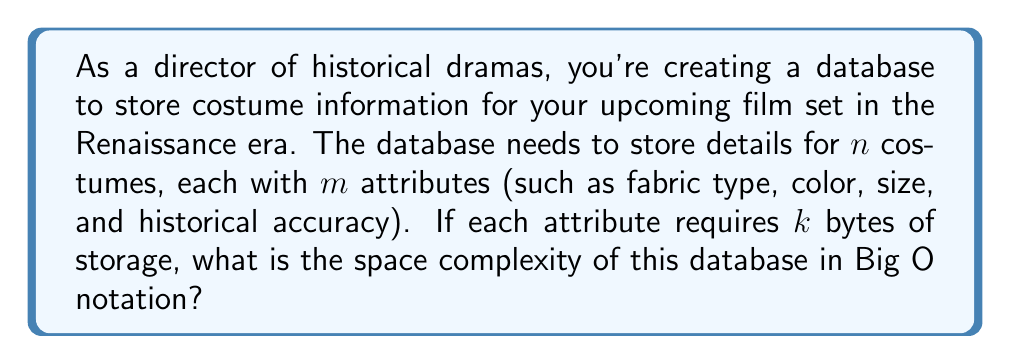Can you solve this math problem? To determine the space complexity of the database, we need to analyze the storage requirements:

1. Number of costumes: $n$
2. Number of attributes per costume: $m$
3. Storage size per attribute: $k$ bytes

For each costume, we store $m$ attributes, and each attribute takes up $k$ bytes. So, the storage required for one costume is:

$$\text{Storage per costume} = m \cdot k \text{ bytes}$$

Now, we have $n$ costumes in total, so the total storage required is:

$$\text{Total storage} = n \cdot (m \cdot k) \text{ bytes}$$

To express this in Big O notation, we focus on how the storage grows with respect to the input size. In this case, the input size is primarily determined by the number of costumes ($n$) and the number of attributes per costume ($m$).

The constants ($k$) are typically ignored in Big O notation unless they are extremely large. Therefore, we can simplify our expression to:

$$O(n \cdot m)$$

This indicates that the space complexity grows linearly with both the number of costumes and the number of attributes per costume.

In the context of database design, this is often referred to as $O(nm)$ space complexity, where $n$ represents the number of records (costumes) and $m$ represents the number of fields (attributes) per record.
Answer: $O(nm)$ 